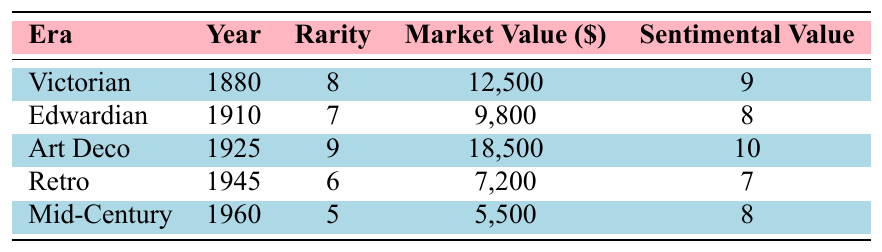What is the market value of the Art Deco ring? The market value of the Art Deco Emerald Cut ring, which is listed in the table under the Art Deco era, is found directly in the corresponding column. It states a market value of $18,500.
Answer: 18500 Which era has the highest rarity rating? By inspecting the rarity column, we see the Art Deco ring has a rarity rating of 9, which is the highest among all eras listed.
Answer: Art Deco What is the sentimental value of the Victorian Sapphire Halo ring? The sentimental value for the Victorian Sapphire Halo ring is directly displayed in the table as a value of 9.
Answer: 9 How much more is the market value of the Victorian ring compared to the Mid-Century ring? The Victorian Sapphire Halo ring has a market value of $12,500 and the Mid-Century Toi et Moi has a market value of $5,500. The difference is calculated as $12,500 - $5,500 = $7,000.
Answer: 7000 Which era has a market value below $10,000? Examining the market value column, the Edwardian Diamond Filigree ring ($9,800), and the Retro Ruby Cluster ring ($7,200) are both below $10,000, confirming their eras correspond to lower market values.
Answer: Edwardian, Retro What is the average sentimental value of the rings from the Victorian and Edwardian eras? The sentimental values for the Victorian and Edwardian rings are 9 and 8, respectively. Their average is calculated as (9 + 8) / 2 = 8.5.
Answer: 8.5 Is the Retro ring rarer than the Mid-Century ring? The rarity of the Retro Ruby Cluster is 6 while the Mid-Century Toi et Moi has a rarity of 5. Since 6 is greater than 5, the Retro ring is indeed rarer.
Answer: Yes What is the sum of the rarity ratings for all rings listed? The rarity ratings are 8 (Victorian) + 7 (Edwardian) + 9 (Art Deco) + 6 (Retro) + 5 (Mid-Century) which totals to 35.
Answer: 35 In which era was the least expensive ring made? The market values show that the Mid-Century Toi et Moi is the least expensive at $5,500, which can be confirmed by directly referencing the corresponding column.
Answer: Mid-Century What is the relationship between rarity and market value for the Victorian ring? The Victorian Sapphire Halo has a rarity of 8 and a market value of $12,500. While we can only assess based on this single data point, typically a higher rarity correlates with a higher market value, which is true in this case.
Answer: Positive correlation Which ring has the highest sentimental value? The Art Deco Emerald Cut ring lists a sentimental value of 10, which is higher than all the others, making it the highest in this category.
Answer: Art Deco Emerald Cut 